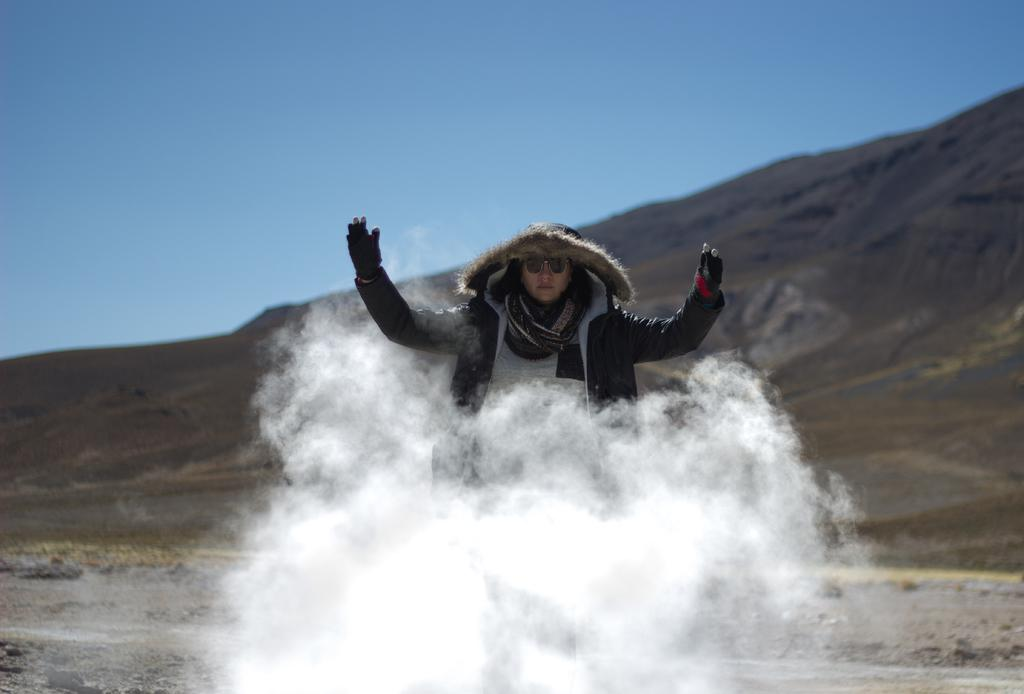What is the main subject of the image? The main subject of the image is a woman. Can you describe the position of the woman in the image? The woman is in the center of the image. What is visible in front of the woman? There is smoke visible in front of the woman. Can you tell me how many cattle are grazing behind the woman in the image? There are no cattle present in the image. What type of hose is being used by the woman in the image? There is no hose visible in the image. 